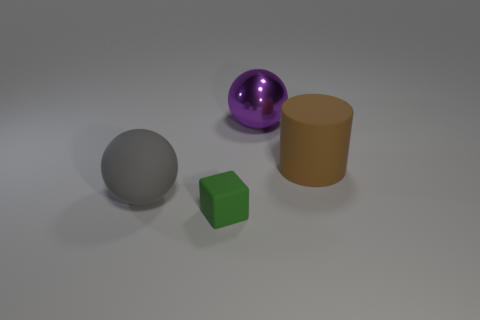Add 1 small red objects. How many objects exist? 5 Subtract all cylinders. How many objects are left? 3 Add 4 big matte blocks. How many big matte blocks exist? 4 Subtract 0 green cylinders. How many objects are left? 4 Subtract all small brown blocks. Subtract all small rubber objects. How many objects are left? 3 Add 2 purple things. How many purple things are left? 3 